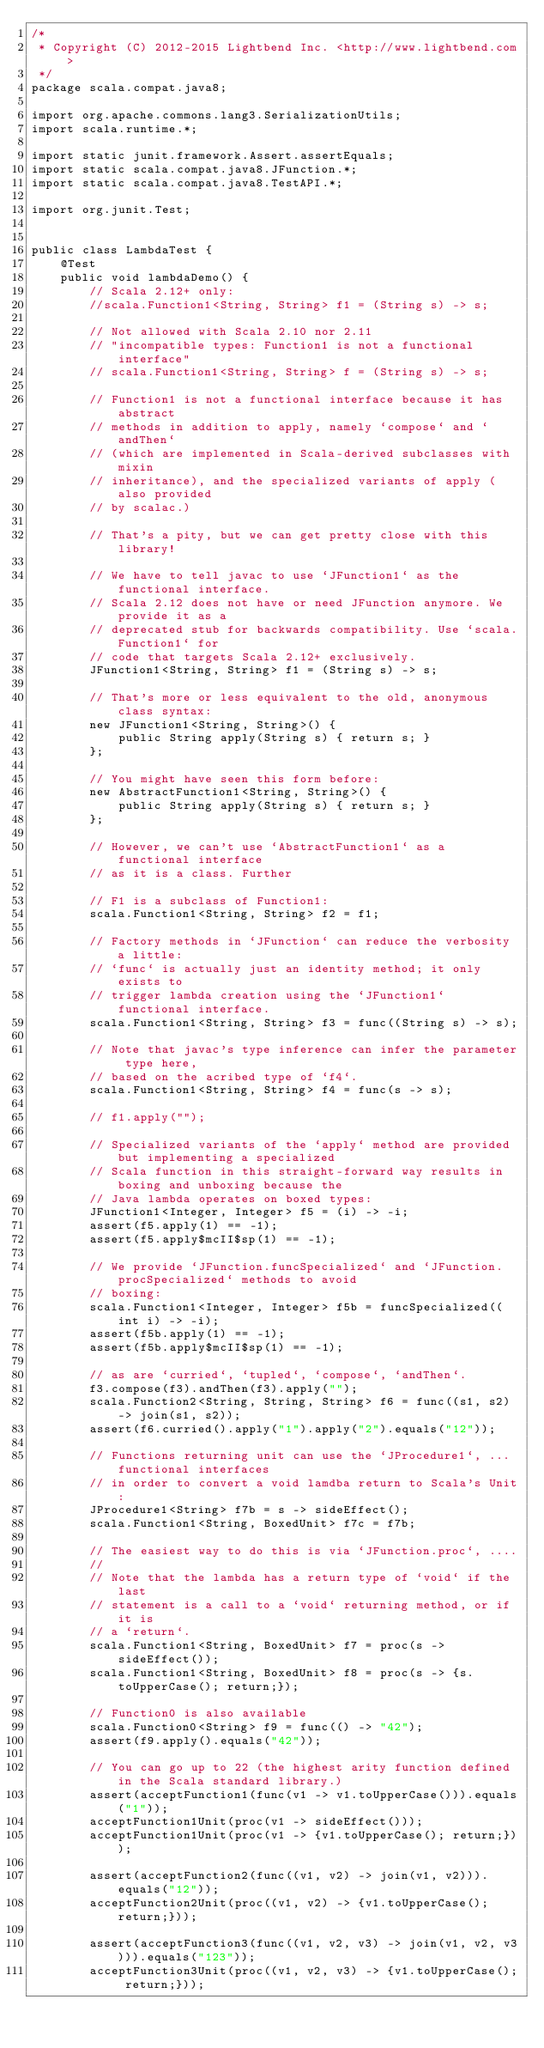Convert code to text. <code><loc_0><loc_0><loc_500><loc_500><_Java_>/*
 * Copyright (C) 2012-2015 Lightbend Inc. <http://www.lightbend.com>
 */
package scala.compat.java8;

import org.apache.commons.lang3.SerializationUtils;
import scala.runtime.*;

import static junit.framework.Assert.assertEquals;
import static scala.compat.java8.JFunction.*;
import static scala.compat.java8.TestAPI.*;

import org.junit.Test;


public class LambdaTest {
    @Test
    public void lambdaDemo() {
        // Scala 2.12+ only:
        //scala.Function1<String, String> f1 = (String s) -> s;

        // Not allowed with Scala 2.10 nor 2.11
        // "incompatible types: Function1 is not a functional interface"
        // scala.Function1<String, String> f = (String s) -> s;

        // Function1 is not a functional interface because it has abstract
        // methods in addition to apply, namely `compose` and `andThen`
        // (which are implemented in Scala-derived subclasses with mixin
        // inheritance), and the specialized variants of apply (also provided
        // by scalac.)

        // That's a pity, but we can get pretty close with this library!

        // We have to tell javac to use `JFunction1` as the functional interface.
        // Scala 2.12 does not have or need JFunction anymore. We provide it as a
        // deprecated stub for backwards compatibility. Use `scala.Function1` for
        // code that targets Scala 2.12+ exclusively.
        JFunction1<String, String> f1 = (String s) -> s;

        // That's more or less equivalent to the old, anonymous class syntax:
        new JFunction1<String, String>() {
            public String apply(String s) { return s; }
        };

        // You might have seen this form before:
        new AbstractFunction1<String, String>() {
            public String apply(String s) { return s; }
        };

        // However, we can't use `AbstractFunction1` as a functional interface
        // as it is a class. Further

        // F1 is a subclass of Function1:
        scala.Function1<String, String> f2 = f1;

        // Factory methods in `JFunction` can reduce the verbosity a little:
        // `func` is actually just an identity method; it only exists to
        // trigger lambda creation using the `JFunction1` functional interface.
        scala.Function1<String, String> f3 = func((String s) -> s);

        // Note that javac's type inference can infer the parameter type here,
        // based on the acribed type of `f4`.
        scala.Function1<String, String> f4 = func(s -> s);

        // f1.apply("");

        // Specialized variants of the `apply` method are provided but implementing a specialized
        // Scala function in this straight-forward way results in boxing and unboxing because the
        // Java lambda operates on boxed types:
        JFunction1<Integer, Integer> f5 = (i) -> -i;
        assert(f5.apply(1) == -1);
        assert(f5.apply$mcII$sp(1) == -1);

        // We provide `JFunction.funcSpecialized` and `JFunction.procSpecialized` methods to avoid
        // boxing:
        scala.Function1<Integer, Integer> f5b = funcSpecialized((int i) -> -i);
        assert(f5b.apply(1) == -1);
        assert(f5b.apply$mcII$sp(1) == -1);

        // as are `curried`, `tupled`, `compose`, `andThen`.
        f3.compose(f3).andThen(f3).apply("");
        scala.Function2<String, String, String> f6 = func((s1, s2) -> join(s1, s2));
        assert(f6.curried().apply("1").apply("2").equals("12"));

        // Functions returning unit can use the `JProcedure1`, ... functional interfaces
        // in order to convert a void lamdba return to Scala's Unit:
        JProcedure1<String> f7b = s -> sideEffect();
        scala.Function1<String, BoxedUnit> f7c = f7b;

        // The easiest way to do this is via `JFunction.proc`, ....
        //
        // Note that the lambda has a return type of `void` if the last
        // statement is a call to a `void` returning method, or if it is
        // a `return`.
        scala.Function1<String, BoxedUnit> f7 = proc(s -> sideEffect());
        scala.Function1<String, BoxedUnit> f8 = proc(s -> {s.toUpperCase(); return;});

        // Function0 is also available
        scala.Function0<String> f9 = func(() -> "42");
        assert(f9.apply().equals("42"));

        // You can go up to 22 (the highest arity function defined in the Scala standard library.)
        assert(acceptFunction1(func(v1 -> v1.toUpperCase())).equals("1"));
        acceptFunction1Unit(proc(v1 -> sideEffect()));
        acceptFunction1Unit(proc(v1 -> {v1.toUpperCase(); return;}));

        assert(acceptFunction2(func((v1, v2) -> join(v1, v2))).equals("12"));
        acceptFunction2Unit(proc((v1, v2) -> {v1.toUpperCase(); return;}));

        assert(acceptFunction3(func((v1, v2, v3) -> join(v1, v2, v3))).equals("123"));
        acceptFunction3Unit(proc((v1, v2, v3) -> {v1.toUpperCase(); return;}));
</code> 